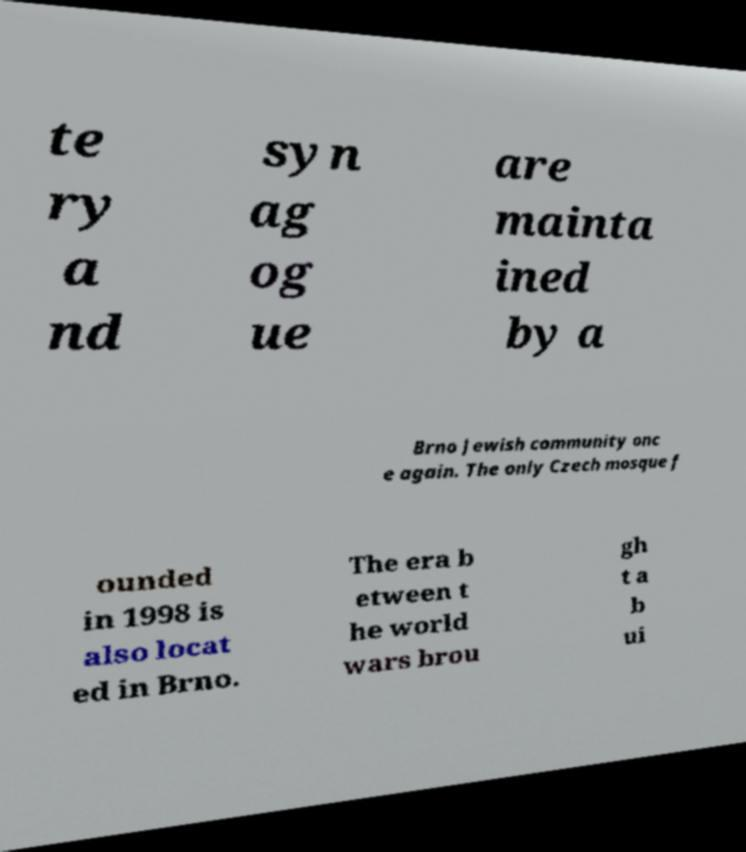Can you read and provide the text displayed in the image?This photo seems to have some interesting text. Can you extract and type it out for me? te ry a nd syn ag og ue are mainta ined by a Brno Jewish community onc e again. The only Czech mosque f ounded in 1998 is also locat ed in Brno. The era b etween t he world wars brou gh t a b ui 